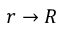Convert formula to latex. <formula><loc_0><loc_0><loc_500><loc_500>r \to R</formula> 